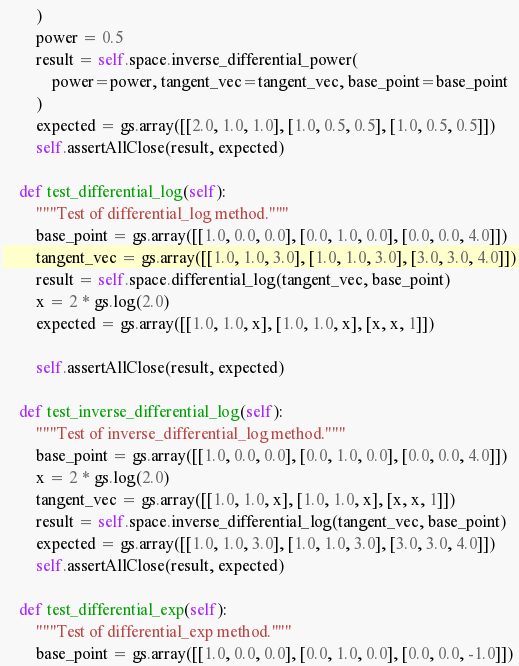Convert code to text. <code><loc_0><loc_0><loc_500><loc_500><_Python_>        )
        power = 0.5
        result = self.space.inverse_differential_power(
            power=power, tangent_vec=tangent_vec, base_point=base_point
        )
        expected = gs.array([[2.0, 1.0, 1.0], [1.0, 0.5, 0.5], [1.0, 0.5, 0.5]])
        self.assertAllClose(result, expected)

    def test_differential_log(self):
        """Test of differential_log method."""
        base_point = gs.array([[1.0, 0.0, 0.0], [0.0, 1.0, 0.0], [0.0, 0.0, 4.0]])
        tangent_vec = gs.array([[1.0, 1.0, 3.0], [1.0, 1.0, 3.0], [3.0, 3.0, 4.0]])
        result = self.space.differential_log(tangent_vec, base_point)
        x = 2 * gs.log(2.0)
        expected = gs.array([[1.0, 1.0, x], [1.0, 1.0, x], [x, x, 1]])

        self.assertAllClose(result, expected)

    def test_inverse_differential_log(self):
        """Test of inverse_differential_log method."""
        base_point = gs.array([[1.0, 0.0, 0.0], [0.0, 1.0, 0.0], [0.0, 0.0, 4.0]])
        x = 2 * gs.log(2.0)
        tangent_vec = gs.array([[1.0, 1.0, x], [1.0, 1.0, x], [x, x, 1]])
        result = self.space.inverse_differential_log(tangent_vec, base_point)
        expected = gs.array([[1.0, 1.0, 3.0], [1.0, 1.0, 3.0], [3.0, 3.0, 4.0]])
        self.assertAllClose(result, expected)

    def test_differential_exp(self):
        """Test of differential_exp method."""
        base_point = gs.array([[1.0, 0.0, 0.0], [0.0, 1.0, 0.0], [0.0, 0.0, -1.0]])</code> 